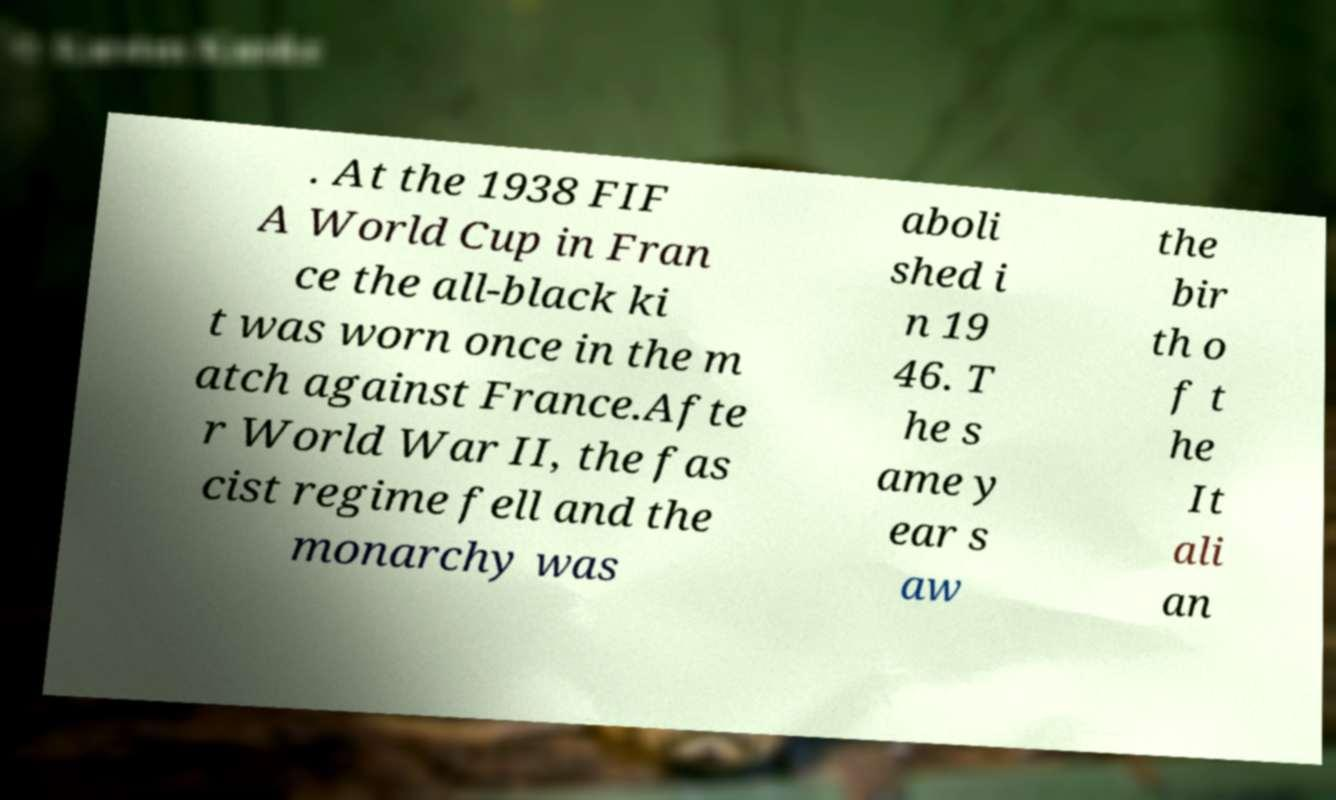There's text embedded in this image that I need extracted. Can you transcribe it verbatim? . At the 1938 FIF A World Cup in Fran ce the all-black ki t was worn once in the m atch against France.Afte r World War II, the fas cist regime fell and the monarchy was aboli shed i n 19 46. T he s ame y ear s aw the bir th o f t he It ali an 